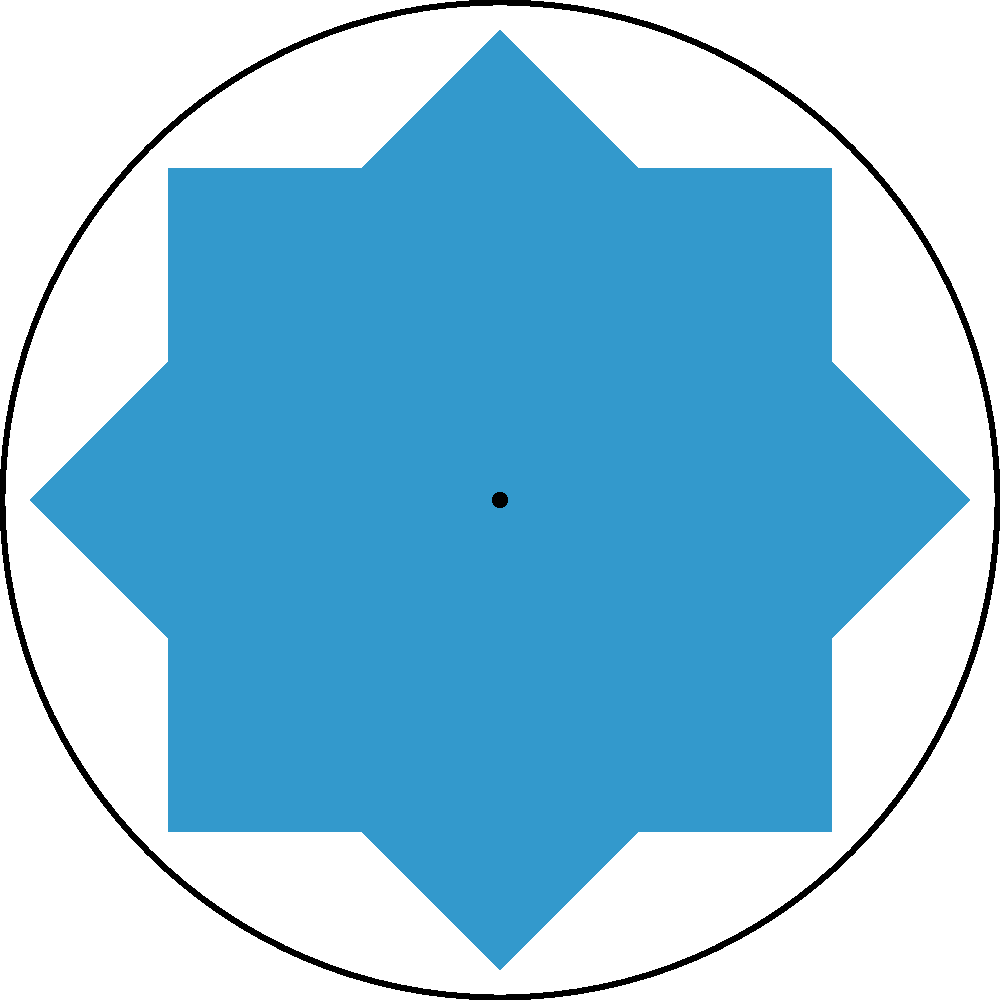In digital media design, rotating shapes can create captivating patterns. Consider a square with side length 1 unit, centered at the origin. If this square is rotated 45° around the origin and then this process is repeated to create a full circular pattern, how many rotations (including the initial position) are needed to complete one full revolution (360°)? To solve this problem, let's break it down step-by-step:

1. We start with a square centered at the origin.
2. Each rotation is 45° around the origin.
3. We need to determine how many 45° rotations are needed to complete 360°.

To calculate this:

1. Set up the equation: $45° \times n = 360°$, where $n$ is the number of rotations.
2. Solve for $n$:
   $n = 360° \div 45°$
   $n = 8$

This means that after 8 rotations (including the initial position), the square will have completed a full 360° revolution, creating a symmetrical, star-like pattern.

In the context of digital media design, this technique can be used to create intricate, mandala-like patterns or dynamic, radial compositions that draw the viewer's eye to the center of the image.
Answer: 8 rotations 